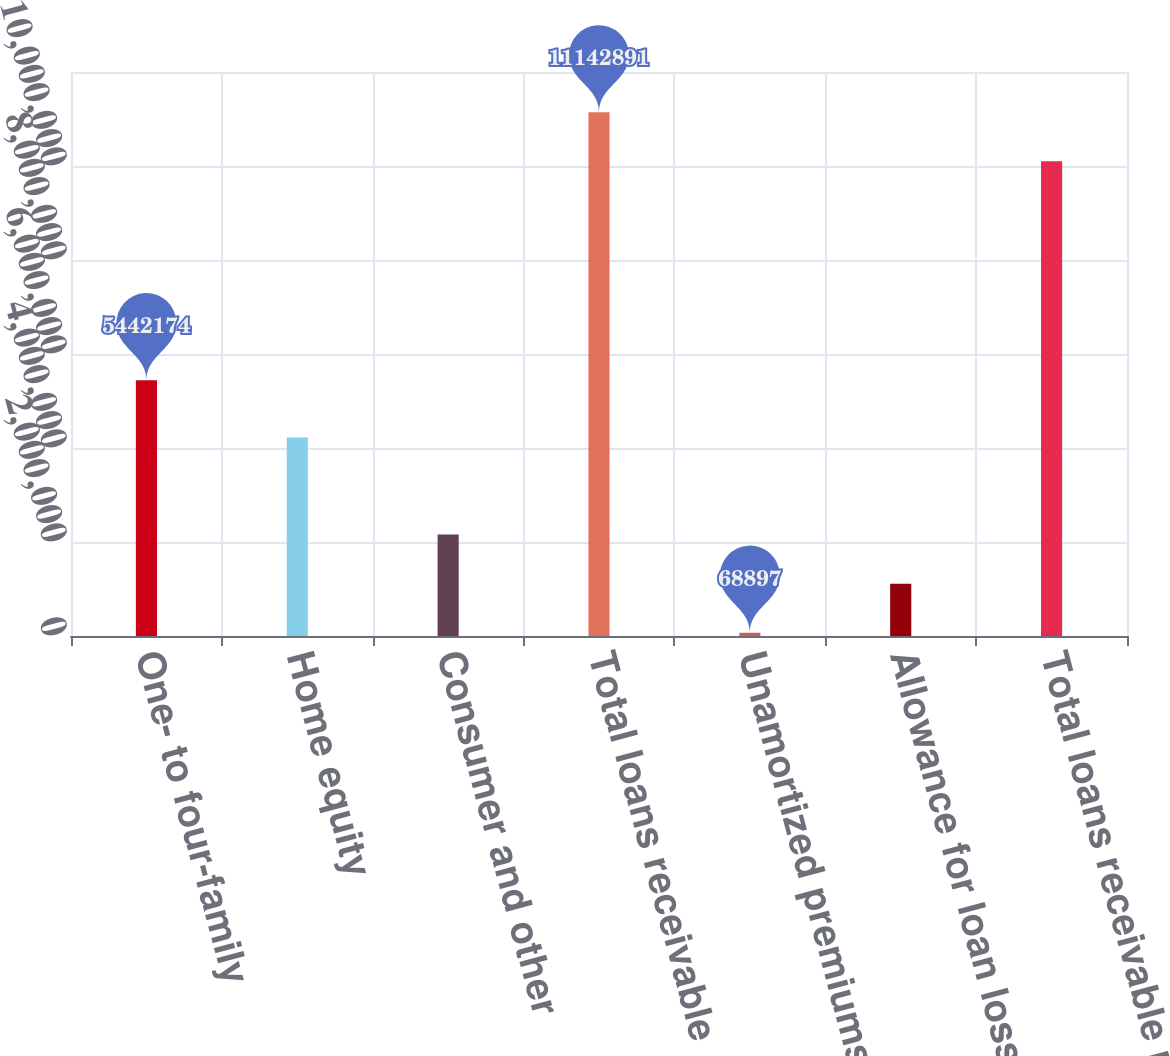Convert chart to OTSL. <chart><loc_0><loc_0><loc_500><loc_500><bar_chart><fcel>One- to four-family<fcel>Home equity<fcel>Consumer and other<fcel>Total loans receivable<fcel>Unamortized premiums net<fcel>Allowance for loan losses<fcel>Total loans receivable net<nl><fcel>5.44217e+06<fcel>4.22346e+06<fcel>2.15723e+06<fcel>1.11429e+07<fcel>68897<fcel>1.11306e+06<fcel>1.00987e+07<nl></chart> 